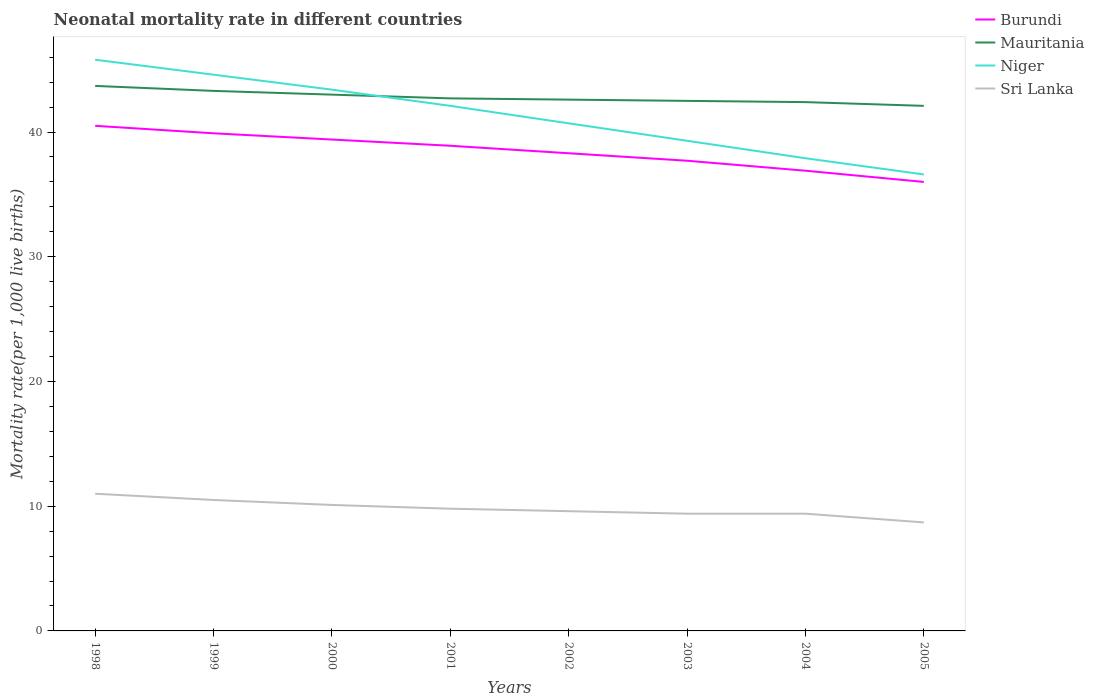How many different coloured lines are there?
Provide a short and direct response. 4. Across all years, what is the maximum neonatal mortality rate in Burundi?
Provide a short and direct response. 36. What is the total neonatal mortality rate in Burundi in the graph?
Provide a succinct answer. 0.5. What is the difference between the highest and the second highest neonatal mortality rate in Sri Lanka?
Keep it short and to the point. 2.3. How many lines are there?
Keep it short and to the point. 4. How many years are there in the graph?
Offer a very short reply. 8. Where does the legend appear in the graph?
Ensure brevity in your answer.  Top right. How are the legend labels stacked?
Ensure brevity in your answer.  Vertical. What is the title of the graph?
Offer a terse response. Neonatal mortality rate in different countries. Does "Aruba" appear as one of the legend labels in the graph?
Your response must be concise. No. What is the label or title of the Y-axis?
Your response must be concise. Mortality rate(per 1,0 live births). What is the Mortality rate(per 1,000 live births) of Burundi in 1998?
Ensure brevity in your answer.  40.5. What is the Mortality rate(per 1,000 live births) in Mauritania in 1998?
Keep it short and to the point. 43.7. What is the Mortality rate(per 1,000 live births) in Niger in 1998?
Ensure brevity in your answer.  45.8. What is the Mortality rate(per 1,000 live births) in Burundi in 1999?
Ensure brevity in your answer.  39.9. What is the Mortality rate(per 1,000 live births) in Mauritania in 1999?
Make the answer very short. 43.3. What is the Mortality rate(per 1,000 live births) of Niger in 1999?
Your answer should be very brief. 44.6. What is the Mortality rate(per 1,000 live births) of Sri Lanka in 1999?
Ensure brevity in your answer.  10.5. What is the Mortality rate(per 1,000 live births) in Burundi in 2000?
Provide a succinct answer. 39.4. What is the Mortality rate(per 1,000 live births) of Niger in 2000?
Your answer should be very brief. 43.4. What is the Mortality rate(per 1,000 live births) of Burundi in 2001?
Your answer should be very brief. 38.9. What is the Mortality rate(per 1,000 live births) of Mauritania in 2001?
Keep it short and to the point. 42.7. What is the Mortality rate(per 1,000 live births) in Niger in 2001?
Give a very brief answer. 42.1. What is the Mortality rate(per 1,000 live births) of Sri Lanka in 2001?
Make the answer very short. 9.8. What is the Mortality rate(per 1,000 live births) in Burundi in 2002?
Provide a short and direct response. 38.3. What is the Mortality rate(per 1,000 live births) in Mauritania in 2002?
Ensure brevity in your answer.  42.6. What is the Mortality rate(per 1,000 live births) of Niger in 2002?
Offer a very short reply. 40.7. What is the Mortality rate(per 1,000 live births) of Burundi in 2003?
Make the answer very short. 37.7. What is the Mortality rate(per 1,000 live births) in Mauritania in 2003?
Your answer should be very brief. 42.5. What is the Mortality rate(per 1,000 live births) of Niger in 2003?
Give a very brief answer. 39.3. What is the Mortality rate(per 1,000 live births) of Sri Lanka in 2003?
Your response must be concise. 9.4. What is the Mortality rate(per 1,000 live births) of Burundi in 2004?
Your answer should be compact. 36.9. What is the Mortality rate(per 1,000 live births) in Mauritania in 2004?
Your answer should be very brief. 42.4. What is the Mortality rate(per 1,000 live births) of Niger in 2004?
Provide a short and direct response. 37.9. What is the Mortality rate(per 1,000 live births) in Mauritania in 2005?
Your answer should be compact. 42.1. What is the Mortality rate(per 1,000 live births) of Niger in 2005?
Make the answer very short. 36.6. Across all years, what is the maximum Mortality rate(per 1,000 live births) in Burundi?
Your response must be concise. 40.5. Across all years, what is the maximum Mortality rate(per 1,000 live births) in Mauritania?
Make the answer very short. 43.7. Across all years, what is the maximum Mortality rate(per 1,000 live births) of Niger?
Make the answer very short. 45.8. Across all years, what is the minimum Mortality rate(per 1,000 live births) of Mauritania?
Provide a short and direct response. 42.1. Across all years, what is the minimum Mortality rate(per 1,000 live births) in Niger?
Your answer should be compact. 36.6. Across all years, what is the minimum Mortality rate(per 1,000 live births) of Sri Lanka?
Offer a terse response. 8.7. What is the total Mortality rate(per 1,000 live births) in Burundi in the graph?
Make the answer very short. 307.6. What is the total Mortality rate(per 1,000 live births) in Mauritania in the graph?
Ensure brevity in your answer.  342.3. What is the total Mortality rate(per 1,000 live births) of Niger in the graph?
Provide a succinct answer. 330.4. What is the total Mortality rate(per 1,000 live births) in Sri Lanka in the graph?
Keep it short and to the point. 78.5. What is the difference between the Mortality rate(per 1,000 live births) in Mauritania in 1998 and that in 1999?
Provide a succinct answer. 0.4. What is the difference between the Mortality rate(per 1,000 live births) in Niger in 1998 and that in 1999?
Your response must be concise. 1.2. What is the difference between the Mortality rate(per 1,000 live births) of Sri Lanka in 1998 and that in 1999?
Provide a succinct answer. 0.5. What is the difference between the Mortality rate(per 1,000 live births) of Mauritania in 1998 and that in 2000?
Provide a succinct answer. 0.7. What is the difference between the Mortality rate(per 1,000 live births) in Niger in 1998 and that in 2000?
Provide a succinct answer. 2.4. What is the difference between the Mortality rate(per 1,000 live births) in Sri Lanka in 1998 and that in 2000?
Provide a short and direct response. 0.9. What is the difference between the Mortality rate(per 1,000 live births) in Burundi in 1998 and that in 2001?
Offer a terse response. 1.6. What is the difference between the Mortality rate(per 1,000 live births) of Sri Lanka in 1998 and that in 2001?
Make the answer very short. 1.2. What is the difference between the Mortality rate(per 1,000 live births) in Burundi in 1998 and that in 2002?
Your answer should be very brief. 2.2. What is the difference between the Mortality rate(per 1,000 live births) in Niger in 1998 and that in 2002?
Your answer should be compact. 5.1. What is the difference between the Mortality rate(per 1,000 live births) of Burundi in 1998 and that in 2003?
Offer a terse response. 2.8. What is the difference between the Mortality rate(per 1,000 live births) in Mauritania in 1998 and that in 2003?
Provide a succinct answer. 1.2. What is the difference between the Mortality rate(per 1,000 live births) in Burundi in 1998 and that in 2004?
Offer a very short reply. 3.6. What is the difference between the Mortality rate(per 1,000 live births) of Mauritania in 1998 and that in 2004?
Offer a very short reply. 1.3. What is the difference between the Mortality rate(per 1,000 live births) in Niger in 1998 and that in 2004?
Keep it short and to the point. 7.9. What is the difference between the Mortality rate(per 1,000 live births) in Burundi in 1998 and that in 2005?
Ensure brevity in your answer.  4.5. What is the difference between the Mortality rate(per 1,000 live births) in Mauritania in 1998 and that in 2005?
Make the answer very short. 1.6. What is the difference between the Mortality rate(per 1,000 live births) of Sri Lanka in 1998 and that in 2005?
Offer a very short reply. 2.3. What is the difference between the Mortality rate(per 1,000 live births) of Burundi in 1999 and that in 2000?
Give a very brief answer. 0.5. What is the difference between the Mortality rate(per 1,000 live births) in Burundi in 1999 and that in 2001?
Offer a terse response. 1. What is the difference between the Mortality rate(per 1,000 live births) in Mauritania in 1999 and that in 2001?
Ensure brevity in your answer.  0.6. What is the difference between the Mortality rate(per 1,000 live births) in Niger in 1999 and that in 2001?
Give a very brief answer. 2.5. What is the difference between the Mortality rate(per 1,000 live births) of Sri Lanka in 1999 and that in 2001?
Your answer should be very brief. 0.7. What is the difference between the Mortality rate(per 1,000 live births) of Mauritania in 1999 and that in 2002?
Provide a short and direct response. 0.7. What is the difference between the Mortality rate(per 1,000 live births) in Niger in 1999 and that in 2002?
Your answer should be very brief. 3.9. What is the difference between the Mortality rate(per 1,000 live births) in Sri Lanka in 1999 and that in 2002?
Offer a terse response. 0.9. What is the difference between the Mortality rate(per 1,000 live births) of Mauritania in 1999 and that in 2003?
Make the answer very short. 0.8. What is the difference between the Mortality rate(per 1,000 live births) of Niger in 1999 and that in 2003?
Your response must be concise. 5.3. What is the difference between the Mortality rate(per 1,000 live births) in Sri Lanka in 1999 and that in 2003?
Keep it short and to the point. 1.1. What is the difference between the Mortality rate(per 1,000 live births) in Mauritania in 1999 and that in 2004?
Provide a short and direct response. 0.9. What is the difference between the Mortality rate(per 1,000 live births) in Niger in 1999 and that in 2004?
Make the answer very short. 6.7. What is the difference between the Mortality rate(per 1,000 live births) of Sri Lanka in 1999 and that in 2004?
Provide a short and direct response. 1.1. What is the difference between the Mortality rate(per 1,000 live births) of Burundi in 1999 and that in 2005?
Offer a very short reply. 3.9. What is the difference between the Mortality rate(per 1,000 live births) of Sri Lanka in 1999 and that in 2005?
Offer a terse response. 1.8. What is the difference between the Mortality rate(per 1,000 live births) of Burundi in 2000 and that in 2001?
Your answer should be compact. 0.5. What is the difference between the Mortality rate(per 1,000 live births) in Mauritania in 2000 and that in 2001?
Offer a very short reply. 0.3. What is the difference between the Mortality rate(per 1,000 live births) of Burundi in 2000 and that in 2002?
Make the answer very short. 1.1. What is the difference between the Mortality rate(per 1,000 live births) in Mauritania in 2000 and that in 2002?
Your response must be concise. 0.4. What is the difference between the Mortality rate(per 1,000 live births) in Sri Lanka in 2000 and that in 2002?
Make the answer very short. 0.5. What is the difference between the Mortality rate(per 1,000 live births) in Mauritania in 2000 and that in 2003?
Your answer should be very brief. 0.5. What is the difference between the Mortality rate(per 1,000 live births) in Niger in 2000 and that in 2003?
Offer a very short reply. 4.1. What is the difference between the Mortality rate(per 1,000 live births) in Sri Lanka in 2000 and that in 2003?
Provide a short and direct response. 0.7. What is the difference between the Mortality rate(per 1,000 live births) of Burundi in 2000 and that in 2004?
Your answer should be very brief. 2.5. What is the difference between the Mortality rate(per 1,000 live births) of Niger in 2000 and that in 2004?
Keep it short and to the point. 5.5. What is the difference between the Mortality rate(per 1,000 live births) of Sri Lanka in 2000 and that in 2004?
Offer a very short reply. 0.7. What is the difference between the Mortality rate(per 1,000 live births) in Burundi in 2000 and that in 2005?
Keep it short and to the point. 3.4. What is the difference between the Mortality rate(per 1,000 live births) in Mauritania in 2000 and that in 2005?
Give a very brief answer. 0.9. What is the difference between the Mortality rate(per 1,000 live births) of Sri Lanka in 2000 and that in 2005?
Ensure brevity in your answer.  1.4. What is the difference between the Mortality rate(per 1,000 live births) of Burundi in 2001 and that in 2002?
Provide a succinct answer. 0.6. What is the difference between the Mortality rate(per 1,000 live births) of Mauritania in 2001 and that in 2002?
Provide a short and direct response. 0.1. What is the difference between the Mortality rate(per 1,000 live births) in Niger in 2001 and that in 2002?
Provide a short and direct response. 1.4. What is the difference between the Mortality rate(per 1,000 live births) of Sri Lanka in 2001 and that in 2002?
Make the answer very short. 0.2. What is the difference between the Mortality rate(per 1,000 live births) in Mauritania in 2001 and that in 2003?
Your answer should be compact. 0.2. What is the difference between the Mortality rate(per 1,000 live births) in Niger in 2001 and that in 2003?
Provide a short and direct response. 2.8. What is the difference between the Mortality rate(per 1,000 live births) of Burundi in 2001 and that in 2004?
Offer a very short reply. 2. What is the difference between the Mortality rate(per 1,000 live births) of Burundi in 2001 and that in 2005?
Your response must be concise. 2.9. What is the difference between the Mortality rate(per 1,000 live births) of Niger in 2001 and that in 2005?
Make the answer very short. 5.5. What is the difference between the Mortality rate(per 1,000 live births) of Niger in 2002 and that in 2003?
Your response must be concise. 1.4. What is the difference between the Mortality rate(per 1,000 live births) in Sri Lanka in 2002 and that in 2003?
Your response must be concise. 0.2. What is the difference between the Mortality rate(per 1,000 live births) of Burundi in 2002 and that in 2005?
Keep it short and to the point. 2.3. What is the difference between the Mortality rate(per 1,000 live births) in Niger in 2002 and that in 2005?
Provide a succinct answer. 4.1. What is the difference between the Mortality rate(per 1,000 live births) of Sri Lanka in 2002 and that in 2005?
Make the answer very short. 0.9. What is the difference between the Mortality rate(per 1,000 live births) in Burundi in 2003 and that in 2004?
Offer a very short reply. 0.8. What is the difference between the Mortality rate(per 1,000 live births) of Mauritania in 2003 and that in 2004?
Keep it short and to the point. 0.1. What is the difference between the Mortality rate(per 1,000 live births) in Sri Lanka in 2003 and that in 2004?
Provide a short and direct response. 0. What is the difference between the Mortality rate(per 1,000 live births) of Niger in 2003 and that in 2005?
Provide a short and direct response. 2.7. What is the difference between the Mortality rate(per 1,000 live births) in Sri Lanka in 2003 and that in 2005?
Offer a very short reply. 0.7. What is the difference between the Mortality rate(per 1,000 live births) of Burundi in 2004 and that in 2005?
Provide a succinct answer. 0.9. What is the difference between the Mortality rate(per 1,000 live births) of Mauritania in 2004 and that in 2005?
Keep it short and to the point. 0.3. What is the difference between the Mortality rate(per 1,000 live births) of Niger in 2004 and that in 2005?
Your answer should be compact. 1.3. What is the difference between the Mortality rate(per 1,000 live births) of Sri Lanka in 2004 and that in 2005?
Make the answer very short. 0.7. What is the difference between the Mortality rate(per 1,000 live births) of Burundi in 1998 and the Mortality rate(per 1,000 live births) of Mauritania in 1999?
Offer a terse response. -2.8. What is the difference between the Mortality rate(per 1,000 live births) in Mauritania in 1998 and the Mortality rate(per 1,000 live births) in Niger in 1999?
Ensure brevity in your answer.  -0.9. What is the difference between the Mortality rate(per 1,000 live births) of Mauritania in 1998 and the Mortality rate(per 1,000 live births) of Sri Lanka in 1999?
Make the answer very short. 33.2. What is the difference between the Mortality rate(per 1,000 live births) of Niger in 1998 and the Mortality rate(per 1,000 live births) of Sri Lanka in 1999?
Keep it short and to the point. 35.3. What is the difference between the Mortality rate(per 1,000 live births) of Burundi in 1998 and the Mortality rate(per 1,000 live births) of Mauritania in 2000?
Provide a short and direct response. -2.5. What is the difference between the Mortality rate(per 1,000 live births) of Burundi in 1998 and the Mortality rate(per 1,000 live births) of Sri Lanka in 2000?
Provide a succinct answer. 30.4. What is the difference between the Mortality rate(per 1,000 live births) in Mauritania in 1998 and the Mortality rate(per 1,000 live births) in Sri Lanka in 2000?
Ensure brevity in your answer.  33.6. What is the difference between the Mortality rate(per 1,000 live births) in Niger in 1998 and the Mortality rate(per 1,000 live births) in Sri Lanka in 2000?
Offer a very short reply. 35.7. What is the difference between the Mortality rate(per 1,000 live births) in Burundi in 1998 and the Mortality rate(per 1,000 live births) in Mauritania in 2001?
Ensure brevity in your answer.  -2.2. What is the difference between the Mortality rate(per 1,000 live births) in Burundi in 1998 and the Mortality rate(per 1,000 live births) in Niger in 2001?
Provide a short and direct response. -1.6. What is the difference between the Mortality rate(per 1,000 live births) in Burundi in 1998 and the Mortality rate(per 1,000 live births) in Sri Lanka in 2001?
Your response must be concise. 30.7. What is the difference between the Mortality rate(per 1,000 live births) in Mauritania in 1998 and the Mortality rate(per 1,000 live births) in Sri Lanka in 2001?
Provide a succinct answer. 33.9. What is the difference between the Mortality rate(per 1,000 live births) of Burundi in 1998 and the Mortality rate(per 1,000 live births) of Sri Lanka in 2002?
Offer a very short reply. 30.9. What is the difference between the Mortality rate(per 1,000 live births) in Mauritania in 1998 and the Mortality rate(per 1,000 live births) in Niger in 2002?
Ensure brevity in your answer.  3. What is the difference between the Mortality rate(per 1,000 live births) in Mauritania in 1998 and the Mortality rate(per 1,000 live births) in Sri Lanka in 2002?
Your answer should be compact. 34.1. What is the difference between the Mortality rate(per 1,000 live births) in Niger in 1998 and the Mortality rate(per 1,000 live births) in Sri Lanka in 2002?
Give a very brief answer. 36.2. What is the difference between the Mortality rate(per 1,000 live births) of Burundi in 1998 and the Mortality rate(per 1,000 live births) of Mauritania in 2003?
Provide a succinct answer. -2. What is the difference between the Mortality rate(per 1,000 live births) of Burundi in 1998 and the Mortality rate(per 1,000 live births) of Sri Lanka in 2003?
Offer a terse response. 31.1. What is the difference between the Mortality rate(per 1,000 live births) of Mauritania in 1998 and the Mortality rate(per 1,000 live births) of Sri Lanka in 2003?
Give a very brief answer. 34.3. What is the difference between the Mortality rate(per 1,000 live births) of Niger in 1998 and the Mortality rate(per 1,000 live births) of Sri Lanka in 2003?
Offer a terse response. 36.4. What is the difference between the Mortality rate(per 1,000 live births) in Burundi in 1998 and the Mortality rate(per 1,000 live births) in Mauritania in 2004?
Your answer should be compact. -1.9. What is the difference between the Mortality rate(per 1,000 live births) of Burundi in 1998 and the Mortality rate(per 1,000 live births) of Niger in 2004?
Provide a short and direct response. 2.6. What is the difference between the Mortality rate(per 1,000 live births) in Burundi in 1998 and the Mortality rate(per 1,000 live births) in Sri Lanka in 2004?
Your answer should be compact. 31.1. What is the difference between the Mortality rate(per 1,000 live births) in Mauritania in 1998 and the Mortality rate(per 1,000 live births) in Sri Lanka in 2004?
Keep it short and to the point. 34.3. What is the difference between the Mortality rate(per 1,000 live births) in Niger in 1998 and the Mortality rate(per 1,000 live births) in Sri Lanka in 2004?
Offer a very short reply. 36.4. What is the difference between the Mortality rate(per 1,000 live births) in Burundi in 1998 and the Mortality rate(per 1,000 live births) in Mauritania in 2005?
Make the answer very short. -1.6. What is the difference between the Mortality rate(per 1,000 live births) of Burundi in 1998 and the Mortality rate(per 1,000 live births) of Sri Lanka in 2005?
Your response must be concise. 31.8. What is the difference between the Mortality rate(per 1,000 live births) in Mauritania in 1998 and the Mortality rate(per 1,000 live births) in Niger in 2005?
Your answer should be compact. 7.1. What is the difference between the Mortality rate(per 1,000 live births) in Niger in 1998 and the Mortality rate(per 1,000 live births) in Sri Lanka in 2005?
Keep it short and to the point. 37.1. What is the difference between the Mortality rate(per 1,000 live births) in Burundi in 1999 and the Mortality rate(per 1,000 live births) in Sri Lanka in 2000?
Make the answer very short. 29.8. What is the difference between the Mortality rate(per 1,000 live births) of Mauritania in 1999 and the Mortality rate(per 1,000 live births) of Niger in 2000?
Offer a very short reply. -0.1. What is the difference between the Mortality rate(per 1,000 live births) of Mauritania in 1999 and the Mortality rate(per 1,000 live births) of Sri Lanka in 2000?
Offer a terse response. 33.2. What is the difference between the Mortality rate(per 1,000 live births) in Niger in 1999 and the Mortality rate(per 1,000 live births) in Sri Lanka in 2000?
Your answer should be very brief. 34.5. What is the difference between the Mortality rate(per 1,000 live births) of Burundi in 1999 and the Mortality rate(per 1,000 live births) of Mauritania in 2001?
Provide a short and direct response. -2.8. What is the difference between the Mortality rate(per 1,000 live births) in Burundi in 1999 and the Mortality rate(per 1,000 live births) in Niger in 2001?
Offer a very short reply. -2.2. What is the difference between the Mortality rate(per 1,000 live births) in Burundi in 1999 and the Mortality rate(per 1,000 live births) in Sri Lanka in 2001?
Provide a short and direct response. 30.1. What is the difference between the Mortality rate(per 1,000 live births) in Mauritania in 1999 and the Mortality rate(per 1,000 live births) in Sri Lanka in 2001?
Provide a succinct answer. 33.5. What is the difference between the Mortality rate(per 1,000 live births) of Niger in 1999 and the Mortality rate(per 1,000 live births) of Sri Lanka in 2001?
Your answer should be compact. 34.8. What is the difference between the Mortality rate(per 1,000 live births) in Burundi in 1999 and the Mortality rate(per 1,000 live births) in Mauritania in 2002?
Keep it short and to the point. -2.7. What is the difference between the Mortality rate(per 1,000 live births) of Burundi in 1999 and the Mortality rate(per 1,000 live births) of Niger in 2002?
Give a very brief answer. -0.8. What is the difference between the Mortality rate(per 1,000 live births) of Burundi in 1999 and the Mortality rate(per 1,000 live births) of Sri Lanka in 2002?
Your answer should be very brief. 30.3. What is the difference between the Mortality rate(per 1,000 live births) of Mauritania in 1999 and the Mortality rate(per 1,000 live births) of Niger in 2002?
Ensure brevity in your answer.  2.6. What is the difference between the Mortality rate(per 1,000 live births) of Mauritania in 1999 and the Mortality rate(per 1,000 live births) of Sri Lanka in 2002?
Your answer should be compact. 33.7. What is the difference between the Mortality rate(per 1,000 live births) of Burundi in 1999 and the Mortality rate(per 1,000 live births) of Niger in 2003?
Make the answer very short. 0.6. What is the difference between the Mortality rate(per 1,000 live births) of Burundi in 1999 and the Mortality rate(per 1,000 live births) of Sri Lanka in 2003?
Make the answer very short. 30.5. What is the difference between the Mortality rate(per 1,000 live births) in Mauritania in 1999 and the Mortality rate(per 1,000 live births) in Niger in 2003?
Provide a short and direct response. 4. What is the difference between the Mortality rate(per 1,000 live births) in Mauritania in 1999 and the Mortality rate(per 1,000 live births) in Sri Lanka in 2003?
Offer a terse response. 33.9. What is the difference between the Mortality rate(per 1,000 live births) of Niger in 1999 and the Mortality rate(per 1,000 live births) of Sri Lanka in 2003?
Your response must be concise. 35.2. What is the difference between the Mortality rate(per 1,000 live births) in Burundi in 1999 and the Mortality rate(per 1,000 live births) in Sri Lanka in 2004?
Provide a short and direct response. 30.5. What is the difference between the Mortality rate(per 1,000 live births) in Mauritania in 1999 and the Mortality rate(per 1,000 live births) in Sri Lanka in 2004?
Your answer should be compact. 33.9. What is the difference between the Mortality rate(per 1,000 live births) of Niger in 1999 and the Mortality rate(per 1,000 live births) of Sri Lanka in 2004?
Provide a succinct answer. 35.2. What is the difference between the Mortality rate(per 1,000 live births) of Burundi in 1999 and the Mortality rate(per 1,000 live births) of Sri Lanka in 2005?
Your response must be concise. 31.2. What is the difference between the Mortality rate(per 1,000 live births) in Mauritania in 1999 and the Mortality rate(per 1,000 live births) in Niger in 2005?
Provide a succinct answer. 6.7. What is the difference between the Mortality rate(per 1,000 live births) of Mauritania in 1999 and the Mortality rate(per 1,000 live births) of Sri Lanka in 2005?
Offer a very short reply. 34.6. What is the difference between the Mortality rate(per 1,000 live births) of Niger in 1999 and the Mortality rate(per 1,000 live births) of Sri Lanka in 2005?
Provide a succinct answer. 35.9. What is the difference between the Mortality rate(per 1,000 live births) of Burundi in 2000 and the Mortality rate(per 1,000 live births) of Sri Lanka in 2001?
Offer a terse response. 29.6. What is the difference between the Mortality rate(per 1,000 live births) in Mauritania in 2000 and the Mortality rate(per 1,000 live births) in Sri Lanka in 2001?
Make the answer very short. 33.2. What is the difference between the Mortality rate(per 1,000 live births) in Niger in 2000 and the Mortality rate(per 1,000 live births) in Sri Lanka in 2001?
Give a very brief answer. 33.6. What is the difference between the Mortality rate(per 1,000 live births) of Burundi in 2000 and the Mortality rate(per 1,000 live births) of Niger in 2002?
Ensure brevity in your answer.  -1.3. What is the difference between the Mortality rate(per 1,000 live births) of Burundi in 2000 and the Mortality rate(per 1,000 live births) of Sri Lanka in 2002?
Provide a short and direct response. 29.8. What is the difference between the Mortality rate(per 1,000 live births) of Mauritania in 2000 and the Mortality rate(per 1,000 live births) of Niger in 2002?
Provide a short and direct response. 2.3. What is the difference between the Mortality rate(per 1,000 live births) of Mauritania in 2000 and the Mortality rate(per 1,000 live births) of Sri Lanka in 2002?
Give a very brief answer. 33.4. What is the difference between the Mortality rate(per 1,000 live births) of Niger in 2000 and the Mortality rate(per 1,000 live births) of Sri Lanka in 2002?
Provide a short and direct response. 33.8. What is the difference between the Mortality rate(per 1,000 live births) in Burundi in 2000 and the Mortality rate(per 1,000 live births) in Niger in 2003?
Give a very brief answer. 0.1. What is the difference between the Mortality rate(per 1,000 live births) of Mauritania in 2000 and the Mortality rate(per 1,000 live births) of Sri Lanka in 2003?
Your answer should be very brief. 33.6. What is the difference between the Mortality rate(per 1,000 live births) in Burundi in 2000 and the Mortality rate(per 1,000 live births) in Mauritania in 2004?
Give a very brief answer. -3. What is the difference between the Mortality rate(per 1,000 live births) in Burundi in 2000 and the Mortality rate(per 1,000 live births) in Niger in 2004?
Make the answer very short. 1.5. What is the difference between the Mortality rate(per 1,000 live births) in Mauritania in 2000 and the Mortality rate(per 1,000 live births) in Sri Lanka in 2004?
Offer a terse response. 33.6. What is the difference between the Mortality rate(per 1,000 live births) in Niger in 2000 and the Mortality rate(per 1,000 live births) in Sri Lanka in 2004?
Offer a terse response. 34. What is the difference between the Mortality rate(per 1,000 live births) in Burundi in 2000 and the Mortality rate(per 1,000 live births) in Sri Lanka in 2005?
Keep it short and to the point. 30.7. What is the difference between the Mortality rate(per 1,000 live births) in Mauritania in 2000 and the Mortality rate(per 1,000 live births) in Sri Lanka in 2005?
Offer a terse response. 34.3. What is the difference between the Mortality rate(per 1,000 live births) of Niger in 2000 and the Mortality rate(per 1,000 live births) of Sri Lanka in 2005?
Provide a succinct answer. 34.7. What is the difference between the Mortality rate(per 1,000 live births) of Burundi in 2001 and the Mortality rate(per 1,000 live births) of Niger in 2002?
Provide a short and direct response. -1.8. What is the difference between the Mortality rate(per 1,000 live births) in Burundi in 2001 and the Mortality rate(per 1,000 live births) in Sri Lanka in 2002?
Provide a succinct answer. 29.3. What is the difference between the Mortality rate(per 1,000 live births) of Mauritania in 2001 and the Mortality rate(per 1,000 live births) of Niger in 2002?
Your answer should be very brief. 2. What is the difference between the Mortality rate(per 1,000 live births) in Mauritania in 2001 and the Mortality rate(per 1,000 live births) in Sri Lanka in 2002?
Ensure brevity in your answer.  33.1. What is the difference between the Mortality rate(per 1,000 live births) of Niger in 2001 and the Mortality rate(per 1,000 live births) of Sri Lanka in 2002?
Ensure brevity in your answer.  32.5. What is the difference between the Mortality rate(per 1,000 live births) in Burundi in 2001 and the Mortality rate(per 1,000 live births) in Sri Lanka in 2003?
Your response must be concise. 29.5. What is the difference between the Mortality rate(per 1,000 live births) of Mauritania in 2001 and the Mortality rate(per 1,000 live births) of Sri Lanka in 2003?
Your answer should be very brief. 33.3. What is the difference between the Mortality rate(per 1,000 live births) of Niger in 2001 and the Mortality rate(per 1,000 live births) of Sri Lanka in 2003?
Your response must be concise. 32.7. What is the difference between the Mortality rate(per 1,000 live births) in Burundi in 2001 and the Mortality rate(per 1,000 live births) in Sri Lanka in 2004?
Provide a short and direct response. 29.5. What is the difference between the Mortality rate(per 1,000 live births) of Mauritania in 2001 and the Mortality rate(per 1,000 live births) of Niger in 2004?
Your response must be concise. 4.8. What is the difference between the Mortality rate(per 1,000 live births) in Mauritania in 2001 and the Mortality rate(per 1,000 live births) in Sri Lanka in 2004?
Make the answer very short. 33.3. What is the difference between the Mortality rate(per 1,000 live births) of Niger in 2001 and the Mortality rate(per 1,000 live births) of Sri Lanka in 2004?
Provide a short and direct response. 32.7. What is the difference between the Mortality rate(per 1,000 live births) in Burundi in 2001 and the Mortality rate(per 1,000 live births) in Mauritania in 2005?
Your response must be concise. -3.2. What is the difference between the Mortality rate(per 1,000 live births) in Burundi in 2001 and the Mortality rate(per 1,000 live births) in Niger in 2005?
Provide a short and direct response. 2.3. What is the difference between the Mortality rate(per 1,000 live births) in Burundi in 2001 and the Mortality rate(per 1,000 live births) in Sri Lanka in 2005?
Keep it short and to the point. 30.2. What is the difference between the Mortality rate(per 1,000 live births) in Mauritania in 2001 and the Mortality rate(per 1,000 live births) in Sri Lanka in 2005?
Offer a very short reply. 34. What is the difference between the Mortality rate(per 1,000 live births) of Niger in 2001 and the Mortality rate(per 1,000 live births) of Sri Lanka in 2005?
Your answer should be very brief. 33.4. What is the difference between the Mortality rate(per 1,000 live births) in Burundi in 2002 and the Mortality rate(per 1,000 live births) in Mauritania in 2003?
Offer a very short reply. -4.2. What is the difference between the Mortality rate(per 1,000 live births) of Burundi in 2002 and the Mortality rate(per 1,000 live births) of Niger in 2003?
Your answer should be very brief. -1. What is the difference between the Mortality rate(per 1,000 live births) in Burundi in 2002 and the Mortality rate(per 1,000 live births) in Sri Lanka in 2003?
Your answer should be very brief. 28.9. What is the difference between the Mortality rate(per 1,000 live births) of Mauritania in 2002 and the Mortality rate(per 1,000 live births) of Sri Lanka in 2003?
Provide a short and direct response. 33.2. What is the difference between the Mortality rate(per 1,000 live births) in Niger in 2002 and the Mortality rate(per 1,000 live births) in Sri Lanka in 2003?
Provide a short and direct response. 31.3. What is the difference between the Mortality rate(per 1,000 live births) of Burundi in 2002 and the Mortality rate(per 1,000 live births) of Mauritania in 2004?
Your response must be concise. -4.1. What is the difference between the Mortality rate(per 1,000 live births) in Burundi in 2002 and the Mortality rate(per 1,000 live births) in Niger in 2004?
Ensure brevity in your answer.  0.4. What is the difference between the Mortality rate(per 1,000 live births) of Burundi in 2002 and the Mortality rate(per 1,000 live births) of Sri Lanka in 2004?
Your response must be concise. 28.9. What is the difference between the Mortality rate(per 1,000 live births) of Mauritania in 2002 and the Mortality rate(per 1,000 live births) of Niger in 2004?
Your answer should be compact. 4.7. What is the difference between the Mortality rate(per 1,000 live births) of Mauritania in 2002 and the Mortality rate(per 1,000 live births) of Sri Lanka in 2004?
Make the answer very short. 33.2. What is the difference between the Mortality rate(per 1,000 live births) of Niger in 2002 and the Mortality rate(per 1,000 live births) of Sri Lanka in 2004?
Keep it short and to the point. 31.3. What is the difference between the Mortality rate(per 1,000 live births) of Burundi in 2002 and the Mortality rate(per 1,000 live births) of Niger in 2005?
Give a very brief answer. 1.7. What is the difference between the Mortality rate(per 1,000 live births) in Burundi in 2002 and the Mortality rate(per 1,000 live births) in Sri Lanka in 2005?
Your response must be concise. 29.6. What is the difference between the Mortality rate(per 1,000 live births) in Mauritania in 2002 and the Mortality rate(per 1,000 live births) in Sri Lanka in 2005?
Provide a succinct answer. 33.9. What is the difference between the Mortality rate(per 1,000 live births) of Niger in 2002 and the Mortality rate(per 1,000 live births) of Sri Lanka in 2005?
Your answer should be compact. 32. What is the difference between the Mortality rate(per 1,000 live births) in Burundi in 2003 and the Mortality rate(per 1,000 live births) in Sri Lanka in 2004?
Provide a short and direct response. 28.3. What is the difference between the Mortality rate(per 1,000 live births) of Mauritania in 2003 and the Mortality rate(per 1,000 live births) of Niger in 2004?
Provide a short and direct response. 4.6. What is the difference between the Mortality rate(per 1,000 live births) of Mauritania in 2003 and the Mortality rate(per 1,000 live births) of Sri Lanka in 2004?
Offer a terse response. 33.1. What is the difference between the Mortality rate(per 1,000 live births) of Niger in 2003 and the Mortality rate(per 1,000 live births) of Sri Lanka in 2004?
Give a very brief answer. 29.9. What is the difference between the Mortality rate(per 1,000 live births) of Burundi in 2003 and the Mortality rate(per 1,000 live births) of Sri Lanka in 2005?
Offer a very short reply. 29. What is the difference between the Mortality rate(per 1,000 live births) of Mauritania in 2003 and the Mortality rate(per 1,000 live births) of Sri Lanka in 2005?
Ensure brevity in your answer.  33.8. What is the difference between the Mortality rate(per 1,000 live births) of Niger in 2003 and the Mortality rate(per 1,000 live births) of Sri Lanka in 2005?
Keep it short and to the point. 30.6. What is the difference between the Mortality rate(per 1,000 live births) of Burundi in 2004 and the Mortality rate(per 1,000 live births) of Niger in 2005?
Your answer should be compact. 0.3. What is the difference between the Mortality rate(per 1,000 live births) of Burundi in 2004 and the Mortality rate(per 1,000 live births) of Sri Lanka in 2005?
Ensure brevity in your answer.  28.2. What is the difference between the Mortality rate(per 1,000 live births) of Mauritania in 2004 and the Mortality rate(per 1,000 live births) of Niger in 2005?
Give a very brief answer. 5.8. What is the difference between the Mortality rate(per 1,000 live births) in Mauritania in 2004 and the Mortality rate(per 1,000 live births) in Sri Lanka in 2005?
Provide a succinct answer. 33.7. What is the difference between the Mortality rate(per 1,000 live births) of Niger in 2004 and the Mortality rate(per 1,000 live births) of Sri Lanka in 2005?
Provide a succinct answer. 29.2. What is the average Mortality rate(per 1,000 live births) in Burundi per year?
Provide a short and direct response. 38.45. What is the average Mortality rate(per 1,000 live births) of Mauritania per year?
Your answer should be compact. 42.79. What is the average Mortality rate(per 1,000 live births) in Niger per year?
Provide a succinct answer. 41.3. What is the average Mortality rate(per 1,000 live births) of Sri Lanka per year?
Provide a succinct answer. 9.81. In the year 1998, what is the difference between the Mortality rate(per 1,000 live births) of Burundi and Mortality rate(per 1,000 live births) of Mauritania?
Make the answer very short. -3.2. In the year 1998, what is the difference between the Mortality rate(per 1,000 live births) of Burundi and Mortality rate(per 1,000 live births) of Sri Lanka?
Offer a terse response. 29.5. In the year 1998, what is the difference between the Mortality rate(per 1,000 live births) of Mauritania and Mortality rate(per 1,000 live births) of Niger?
Your answer should be very brief. -2.1. In the year 1998, what is the difference between the Mortality rate(per 1,000 live births) in Mauritania and Mortality rate(per 1,000 live births) in Sri Lanka?
Your answer should be very brief. 32.7. In the year 1998, what is the difference between the Mortality rate(per 1,000 live births) in Niger and Mortality rate(per 1,000 live births) in Sri Lanka?
Provide a succinct answer. 34.8. In the year 1999, what is the difference between the Mortality rate(per 1,000 live births) in Burundi and Mortality rate(per 1,000 live births) in Niger?
Your answer should be compact. -4.7. In the year 1999, what is the difference between the Mortality rate(per 1,000 live births) of Burundi and Mortality rate(per 1,000 live births) of Sri Lanka?
Your answer should be very brief. 29.4. In the year 1999, what is the difference between the Mortality rate(per 1,000 live births) in Mauritania and Mortality rate(per 1,000 live births) in Niger?
Your response must be concise. -1.3. In the year 1999, what is the difference between the Mortality rate(per 1,000 live births) of Mauritania and Mortality rate(per 1,000 live births) of Sri Lanka?
Provide a short and direct response. 32.8. In the year 1999, what is the difference between the Mortality rate(per 1,000 live births) of Niger and Mortality rate(per 1,000 live births) of Sri Lanka?
Provide a succinct answer. 34.1. In the year 2000, what is the difference between the Mortality rate(per 1,000 live births) in Burundi and Mortality rate(per 1,000 live births) in Niger?
Offer a terse response. -4. In the year 2000, what is the difference between the Mortality rate(per 1,000 live births) of Burundi and Mortality rate(per 1,000 live births) of Sri Lanka?
Your answer should be very brief. 29.3. In the year 2000, what is the difference between the Mortality rate(per 1,000 live births) in Mauritania and Mortality rate(per 1,000 live births) in Sri Lanka?
Your answer should be compact. 32.9. In the year 2000, what is the difference between the Mortality rate(per 1,000 live births) in Niger and Mortality rate(per 1,000 live births) in Sri Lanka?
Provide a succinct answer. 33.3. In the year 2001, what is the difference between the Mortality rate(per 1,000 live births) of Burundi and Mortality rate(per 1,000 live births) of Sri Lanka?
Make the answer very short. 29.1. In the year 2001, what is the difference between the Mortality rate(per 1,000 live births) of Mauritania and Mortality rate(per 1,000 live births) of Niger?
Ensure brevity in your answer.  0.6. In the year 2001, what is the difference between the Mortality rate(per 1,000 live births) of Mauritania and Mortality rate(per 1,000 live births) of Sri Lanka?
Offer a terse response. 32.9. In the year 2001, what is the difference between the Mortality rate(per 1,000 live births) of Niger and Mortality rate(per 1,000 live births) of Sri Lanka?
Offer a terse response. 32.3. In the year 2002, what is the difference between the Mortality rate(per 1,000 live births) of Burundi and Mortality rate(per 1,000 live births) of Mauritania?
Provide a succinct answer. -4.3. In the year 2002, what is the difference between the Mortality rate(per 1,000 live births) in Burundi and Mortality rate(per 1,000 live births) in Niger?
Your response must be concise. -2.4. In the year 2002, what is the difference between the Mortality rate(per 1,000 live births) of Burundi and Mortality rate(per 1,000 live births) of Sri Lanka?
Provide a succinct answer. 28.7. In the year 2002, what is the difference between the Mortality rate(per 1,000 live births) of Mauritania and Mortality rate(per 1,000 live births) of Niger?
Provide a short and direct response. 1.9. In the year 2002, what is the difference between the Mortality rate(per 1,000 live births) of Niger and Mortality rate(per 1,000 live births) of Sri Lanka?
Ensure brevity in your answer.  31.1. In the year 2003, what is the difference between the Mortality rate(per 1,000 live births) of Burundi and Mortality rate(per 1,000 live births) of Mauritania?
Offer a very short reply. -4.8. In the year 2003, what is the difference between the Mortality rate(per 1,000 live births) in Burundi and Mortality rate(per 1,000 live births) in Sri Lanka?
Your answer should be compact. 28.3. In the year 2003, what is the difference between the Mortality rate(per 1,000 live births) in Mauritania and Mortality rate(per 1,000 live births) in Sri Lanka?
Keep it short and to the point. 33.1. In the year 2003, what is the difference between the Mortality rate(per 1,000 live births) in Niger and Mortality rate(per 1,000 live births) in Sri Lanka?
Ensure brevity in your answer.  29.9. In the year 2004, what is the difference between the Mortality rate(per 1,000 live births) of Burundi and Mortality rate(per 1,000 live births) of Niger?
Provide a short and direct response. -1. In the year 2004, what is the difference between the Mortality rate(per 1,000 live births) in Niger and Mortality rate(per 1,000 live births) in Sri Lanka?
Ensure brevity in your answer.  28.5. In the year 2005, what is the difference between the Mortality rate(per 1,000 live births) of Burundi and Mortality rate(per 1,000 live births) of Mauritania?
Give a very brief answer. -6.1. In the year 2005, what is the difference between the Mortality rate(per 1,000 live births) in Burundi and Mortality rate(per 1,000 live births) in Sri Lanka?
Make the answer very short. 27.3. In the year 2005, what is the difference between the Mortality rate(per 1,000 live births) of Mauritania and Mortality rate(per 1,000 live births) of Niger?
Offer a very short reply. 5.5. In the year 2005, what is the difference between the Mortality rate(per 1,000 live births) of Mauritania and Mortality rate(per 1,000 live births) of Sri Lanka?
Your response must be concise. 33.4. In the year 2005, what is the difference between the Mortality rate(per 1,000 live births) in Niger and Mortality rate(per 1,000 live births) in Sri Lanka?
Offer a terse response. 27.9. What is the ratio of the Mortality rate(per 1,000 live births) in Burundi in 1998 to that in 1999?
Provide a succinct answer. 1.01. What is the ratio of the Mortality rate(per 1,000 live births) in Mauritania in 1998 to that in 1999?
Make the answer very short. 1.01. What is the ratio of the Mortality rate(per 1,000 live births) in Niger in 1998 to that in 1999?
Your response must be concise. 1.03. What is the ratio of the Mortality rate(per 1,000 live births) in Sri Lanka in 1998 to that in 1999?
Your answer should be very brief. 1.05. What is the ratio of the Mortality rate(per 1,000 live births) in Burundi in 1998 to that in 2000?
Your response must be concise. 1.03. What is the ratio of the Mortality rate(per 1,000 live births) in Mauritania in 1998 to that in 2000?
Give a very brief answer. 1.02. What is the ratio of the Mortality rate(per 1,000 live births) of Niger in 1998 to that in 2000?
Make the answer very short. 1.06. What is the ratio of the Mortality rate(per 1,000 live births) of Sri Lanka in 1998 to that in 2000?
Your response must be concise. 1.09. What is the ratio of the Mortality rate(per 1,000 live births) of Burundi in 1998 to that in 2001?
Your response must be concise. 1.04. What is the ratio of the Mortality rate(per 1,000 live births) in Mauritania in 1998 to that in 2001?
Provide a short and direct response. 1.02. What is the ratio of the Mortality rate(per 1,000 live births) of Niger in 1998 to that in 2001?
Your answer should be very brief. 1.09. What is the ratio of the Mortality rate(per 1,000 live births) of Sri Lanka in 1998 to that in 2001?
Provide a short and direct response. 1.12. What is the ratio of the Mortality rate(per 1,000 live births) in Burundi in 1998 to that in 2002?
Give a very brief answer. 1.06. What is the ratio of the Mortality rate(per 1,000 live births) in Mauritania in 1998 to that in 2002?
Provide a short and direct response. 1.03. What is the ratio of the Mortality rate(per 1,000 live births) in Niger in 1998 to that in 2002?
Provide a succinct answer. 1.13. What is the ratio of the Mortality rate(per 1,000 live births) in Sri Lanka in 1998 to that in 2002?
Offer a terse response. 1.15. What is the ratio of the Mortality rate(per 1,000 live births) in Burundi in 1998 to that in 2003?
Offer a very short reply. 1.07. What is the ratio of the Mortality rate(per 1,000 live births) of Mauritania in 1998 to that in 2003?
Provide a short and direct response. 1.03. What is the ratio of the Mortality rate(per 1,000 live births) of Niger in 1998 to that in 2003?
Offer a very short reply. 1.17. What is the ratio of the Mortality rate(per 1,000 live births) of Sri Lanka in 1998 to that in 2003?
Your answer should be compact. 1.17. What is the ratio of the Mortality rate(per 1,000 live births) in Burundi in 1998 to that in 2004?
Provide a short and direct response. 1.1. What is the ratio of the Mortality rate(per 1,000 live births) in Mauritania in 1998 to that in 2004?
Provide a short and direct response. 1.03. What is the ratio of the Mortality rate(per 1,000 live births) of Niger in 1998 to that in 2004?
Your response must be concise. 1.21. What is the ratio of the Mortality rate(per 1,000 live births) in Sri Lanka in 1998 to that in 2004?
Offer a very short reply. 1.17. What is the ratio of the Mortality rate(per 1,000 live births) of Burundi in 1998 to that in 2005?
Your response must be concise. 1.12. What is the ratio of the Mortality rate(per 1,000 live births) of Mauritania in 1998 to that in 2005?
Your answer should be compact. 1.04. What is the ratio of the Mortality rate(per 1,000 live births) of Niger in 1998 to that in 2005?
Provide a short and direct response. 1.25. What is the ratio of the Mortality rate(per 1,000 live births) in Sri Lanka in 1998 to that in 2005?
Your answer should be very brief. 1.26. What is the ratio of the Mortality rate(per 1,000 live births) in Burundi in 1999 to that in 2000?
Make the answer very short. 1.01. What is the ratio of the Mortality rate(per 1,000 live births) in Mauritania in 1999 to that in 2000?
Keep it short and to the point. 1.01. What is the ratio of the Mortality rate(per 1,000 live births) in Niger in 1999 to that in 2000?
Ensure brevity in your answer.  1.03. What is the ratio of the Mortality rate(per 1,000 live births) in Sri Lanka in 1999 to that in 2000?
Your answer should be very brief. 1.04. What is the ratio of the Mortality rate(per 1,000 live births) in Burundi in 1999 to that in 2001?
Keep it short and to the point. 1.03. What is the ratio of the Mortality rate(per 1,000 live births) of Mauritania in 1999 to that in 2001?
Provide a succinct answer. 1.01. What is the ratio of the Mortality rate(per 1,000 live births) of Niger in 1999 to that in 2001?
Ensure brevity in your answer.  1.06. What is the ratio of the Mortality rate(per 1,000 live births) of Sri Lanka in 1999 to that in 2001?
Ensure brevity in your answer.  1.07. What is the ratio of the Mortality rate(per 1,000 live births) of Burundi in 1999 to that in 2002?
Make the answer very short. 1.04. What is the ratio of the Mortality rate(per 1,000 live births) of Mauritania in 1999 to that in 2002?
Keep it short and to the point. 1.02. What is the ratio of the Mortality rate(per 1,000 live births) of Niger in 1999 to that in 2002?
Your response must be concise. 1.1. What is the ratio of the Mortality rate(per 1,000 live births) in Sri Lanka in 1999 to that in 2002?
Make the answer very short. 1.09. What is the ratio of the Mortality rate(per 1,000 live births) in Burundi in 1999 to that in 2003?
Offer a terse response. 1.06. What is the ratio of the Mortality rate(per 1,000 live births) in Mauritania in 1999 to that in 2003?
Your response must be concise. 1.02. What is the ratio of the Mortality rate(per 1,000 live births) of Niger in 1999 to that in 2003?
Offer a very short reply. 1.13. What is the ratio of the Mortality rate(per 1,000 live births) in Sri Lanka in 1999 to that in 2003?
Your response must be concise. 1.12. What is the ratio of the Mortality rate(per 1,000 live births) in Burundi in 1999 to that in 2004?
Keep it short and to the point. 1.08. What is the ratio of the Mortality rate(per 1,000 live births) of Mauritania in 1999 to that in 2004?
Your answer should be compact. 1.02. What is the ratio of the Mortality rate(per 1,000 live births) of Niger in 1999 to that in 2004?
Provide a succinct answer. 1.18. What is the ratio of the Mortality rate(per 1,000 live births) of Sri Lanka in 1999 to that in 2004?
Make the answer very short. 1.12. What is the ratio of the Mortality rate(per 1,000 live births) of Burundi in 1999 to that in 2005?
Give a very brief answer. 1.11. What is the ratio of the Mortality rate(per 1,000 live births) of Mauritania in 1999 to that in 2005?
Offer a very short reply. 1.03. What is the ratio of the Mortality rate(per 1,000 live births) of Niger in 1999 to that in 2005?
Your answer should be very brief. 1.22. What is the ratio of the Mortality rate(per 1,000 live births) of Sri Lanka in 1999 to that in 2005?
Your answer should be compact. 1.21. What is the ratio of the Mortality rate(per 1,000 live births) of Burundi in 2000 to that in 2001?
Your response must be concise. 1.01. What is the ratio of the Mortality rate(per 1,000 live births) in Niger in 2000 to that in 2001?
Ensure brevity in your answer.  1.03. What is the ratio of the Mortality rate(per 1,000 live births) in Sri Lanka in 2000 to that in 2001?
Provide a succinct answer. 1.03. What is the ratio of the Mortality rate(per 1,000 live births) of Burundi in 2000 to that in 2002?
Your answer should be compact. 1.03. What is the ratio of the Mortality rate(per 1,000 live births) in Mauritania in 2000 to that in 2002?
Your response must be concise. 1.01. What is the ratio of the Mortality rate(per 1,000 live births) in Niger in 2000 to that in 2002?
Offer a very short reply. 1.07. What is the ratio of the Mortality rate(per 1,000 live births) of Sri Lanka in 2000 to that in 2002?
Make the answer very short. 1.05. What is the ratio of the Mortality rate(per 1,000 live births) in Burundi in 2000 to that in 2003?
Provide a succinct answer. 1.05. What is the ratio of the Mortality rate(per 1,000 live births) in Mauritania in 2000 to that in 2003?
Your response must be concise. 1.01. What is the ratio of the Mortality rate(per 1,000 live births) in Niger in 2000 to that in 2003?
Your response must be concise. 1.1. What is the ratio of the Mortality rate(per 1,000 live births) of Sri Lanka in 2000 to that in 2003?
Make the answer very short. 1.07. What is the ratio of the Mortality rate(per 1,000 live births) in Burundi in 2000 to that in 2004?
Give a very brief answer. 1.07. What is the ratio of the Mortality rate(per 1,000 live births) in Mauritania in 2000 to that in 2004?
Keep it short and to the point. 1.01. What is the ratio of the Mortality rate(per 1,000 live births) of Niger in 2000 to that in 2004?
Your answer should be compact. 1.15. What is the ratio of the Mortality rate(per 1,000 live births) of Sri Lanka in 2000 to that in 2004?
Provide a succinct answer. 1.07. What is the ratio of the Mortality rate(per 1,000 live births) of Burundi in 2000 to that in 2005?
Your answer should be compact. 1.09. What is the ratio of the Mortality rate(per 1,000 live births) in Mauritania in 2000 to that in 2005?
Offer a very short reply. 1.02. What is the ratio of the Mortality rate(per 1,000 live births) of Niger in 2000 to that in 2005?
Keep it short and to the point. 1.19. What is the ratio of the Mortality rate(per 1,000 live births) in Sri Lanka in 2000 to that in 2005?
Your answer should be compact. 1.16. What is the ratio of the Mortality rate(per 1,000 live births) in Burundi in 2001 to that in 2002?
Offer a very short reply. 1.02. What is the ratio of the Mortality rate(per 1,000 live births) of Niger in 2001 to that in 2002?
Make the answer very short. 1.03. What is the ratio of the Mortality rate(per 1,000 live births) in Sri Lanka in 2001 to that in 2002?
Give a very brief answer. 1.02. What is the ratio of the Mortality rate(per 1,000 live births) of Burundi in 2001 to that in 2003?
Your answer should be compact. 1.03. What is the ratio of the Mortality rate(per 1,000 live births) in Mauritania in 2001 to that in 2003?
Your response must be concise. 1. What is the ratio of the Mortality rate(per 1,000 live births) of Niger in 2001 to that in 2003?
Your answer should be compact. 1.07. What is the ratio of the Mortality rate(per 1,000 live births) of Sri Lanka in 2001 to that in 2003?
Provide a short and direct response. 1.04. What is the ratio of the Mortality rate(per 1,000 live births) of Burundi in 2001 to that in 2004?
Provide a short and direct response. 1.05. What is the ratio of the Mortality rate(per 1,000 live births) in Mauritania in 2001 to that in 2004?
Offer a terse response. 1.01. What is the ratio of the Mortality rate(per 1,000 live births) in Niger in 2001 to that in 2004?
Your answer should be compact. 1.11. What is the ratio of the Mortality rate(per 1,000 live births) of Sri Lanka in 2001 to that in 2004?
Keep it short and to the point. 1.04. What is the ratio of the Mortality rate(per 1,000 live births) in Burundi in 2001 to that in 2005?
Your answer should be compact. 1.08. What is the ratio of the Mortality rate(per 1,000 live births) of Mauritania in 2001 to that in 2005?
Ensure brevity in your answer.  1.01. What is the ratio of the Mortality rate(per 1,000 live births) in Niger in 2001 to that in 2005?
Provide a succinct answer. 1.15. What is the ratio of the Mortality rate(per 1,000 live births) in Sri Lanka in 2001 to that in 2005?
Make the answer very short. 1.13. What is the ratio of the Mortality rate(per 1,000 live births) of Burundi in 2002 to that in 2003?
Provide a succinct answer. 1.02. What is the ratio of the Mortality rate(per 1,000 live births) in Niger in 2002 to that in 2003?
Your answer should be compact. 1.04. What is the ratio of the Mortality rate(per 1,000 live births) in Sri Lanka in 2002 to that in 2003?
Your answer should be very brief. 1.02. What is the ratio of the Mortality rate(per 1,000 live births) of Burundi in 2002 to that in 2004?
Provide a short and direct response. 1.04. What is the ratio of the Mortality rate(per 1,000 live births) in Niger in 2002 to that in 2004?
Provide a short and direct response. 1.07. What is the ratio of the Mortality rate(per 1,000 live births) of Sri Lanka in 2002 to that in 2004?
Offer a very short reply. 1.02. What is the ratio of the Mortality rate(per 1,000 live births) in Burundi in 2002 to that in 2005?
Your response must be concise. 1.06. What is the ratio of the Mortality rate(per 1,000 live births) of Mauritania in 2002 to that in 2005?
Give a very brief answer. 1.01. What is the ratio of the Mortality rate(per 1,000 live births) of Niger in 2002 to that in 2005?
Your response must be concise. 1.11. What is the ratio of the Mortality rate(per 1,000 live births) in Sri Lanka in 2002 to that in 2005?
Your response must be concise. 1.1. What is the ratio of the Mortality rate(per 1,000 live births) in Burundi in 2003 to that in 2004?
Your answer should be compact. 1.02. What is the ratio of the Mortality rate(per 1,000 live births) of Niger in 2003 to that in 2004?
Offer a very short reply. 1.04. What is the ratio of the Mortality rate(per 1,000 live births) of Burundi in 2003 to that in 2005?
Give a very brief answer. 1.05. What is the ratio of the Mortality rate(per 1,000 live births) of Mauritania in 2003 to that in 2005?
Your answer should be very brief. 1.01. What is the ratio of the Mortality rate(per 1,000 live births) in Niger in 2003 to that in 2005?
Make the answer very short. 1.07. What is the ratio of the Mortality rate(per 1,000 live births) of Sri Lanka in 2003 to that in 2005?
Offer a terse response. 1.08. What is the ratio of the Mortality rate(per 1,000 live births) in Burundi in 2004 to that in 2005?
Keep it short and to the point. 1.02. What is the ratio of the Mortality rate(per 1,000 live births) of Mauritania in 2004 to that in 2005?
Your answer should be very brief. 1.01. What is the ratio of the Mortality rate(per 1,000 live births) of Niger in 2004 to that in 2005?
Keep it short and to the point. 1.04. What is the ratio of the Mortality rate(per 1,000 live births) of Sri Lanka in 2004 to that in 2005?
Offer a terse response. 1.08. What is the difference between the highest and the second highest Mortality rate(per 1,000 live births) in Burundi?
Ensure brevity in your answer.  0.6. What is the difference between the highest and the second highest Mortality rate(per 1,000 live births) in Mauritania?
Provide a succinct answer. 0.4. What is the difference between the highest and the second highest Mortality rate(per 1,000 live births) in Niger?
Give a very brief answer. 1.2. What is the difference between the highest and the second highest Mortality rate(per 1,000 live births) of Sri Lanka?
Give a very brief answer. 0.5. What is the difference between the highest and the lowest Mortality rate(per 1,000 live births) in Burundi?
Give a very brief answer. 4.5. 